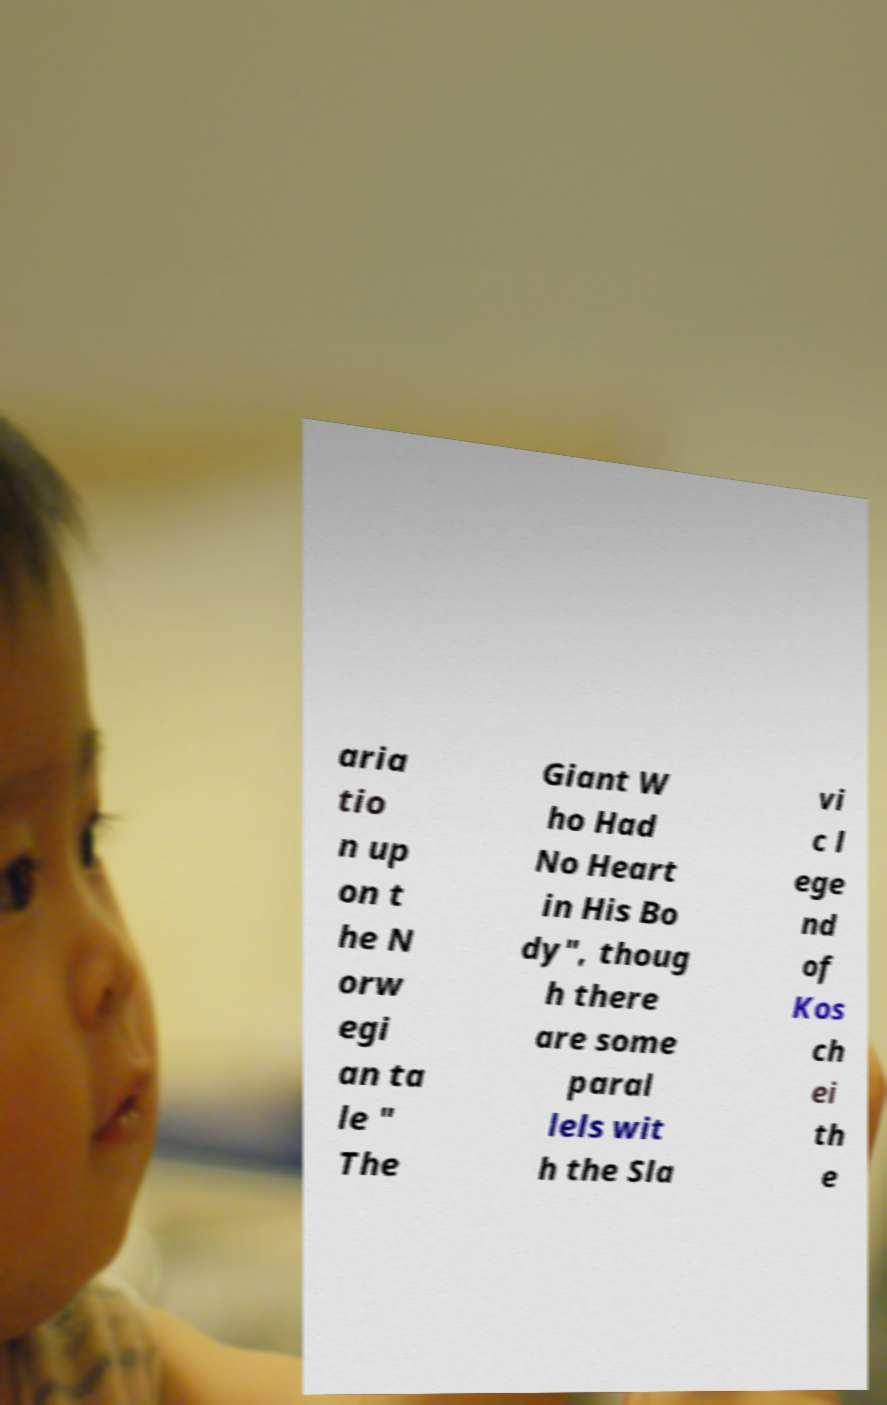Could you assist in decoding the text presented in this image and type it out clearly? aria tio n up on t he N orw egi an ta le " The Giant W ho Had No Heart in His Bo dy", thoug h there are some paral lels wit h the Sla vi c l ege nd of Kos ch ei th e 